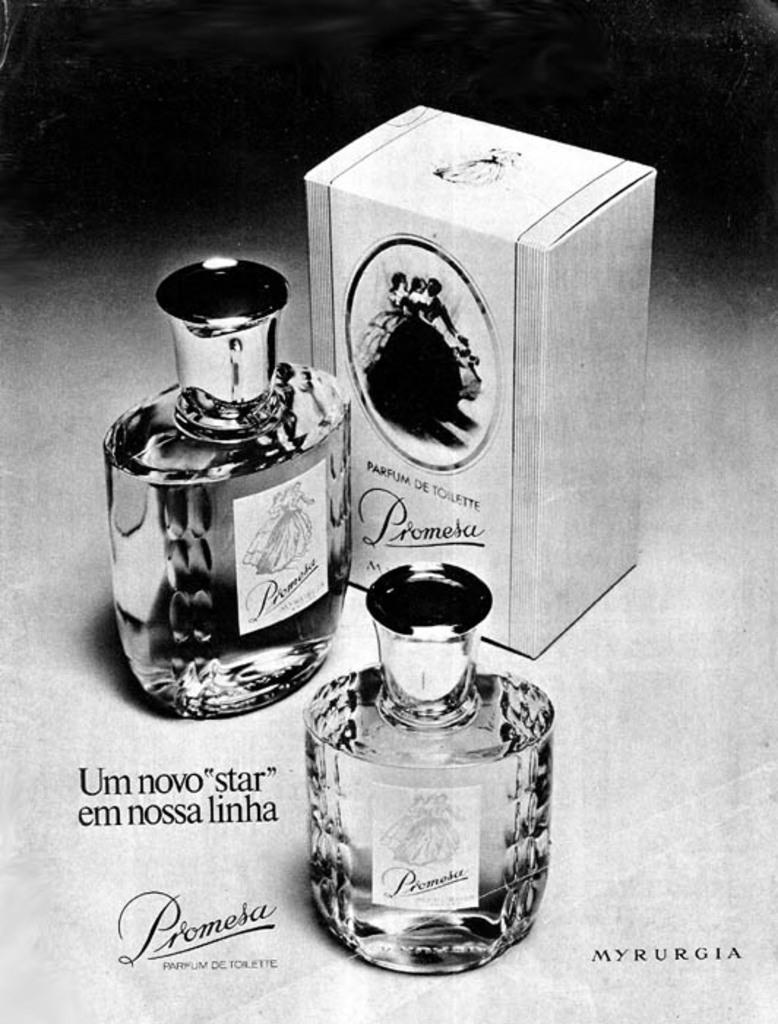Provide a one-sentence caption for the provided image. A perfume ad displaying the perfume Prometa with the perfume box and bottle beside. 